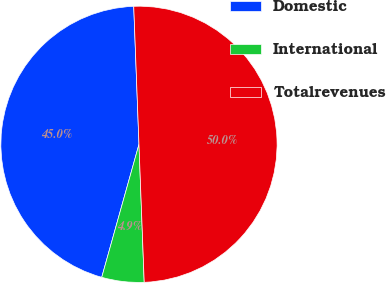<chart> <loc_0><loc_0><loc_500><loc_500><pie_chart><fcel>Domestic<fcel>International<fcel>Totalrevenues<nl><fcel>45.05%<fcel>4.95%<fcel>50.0%<nl></chart> 